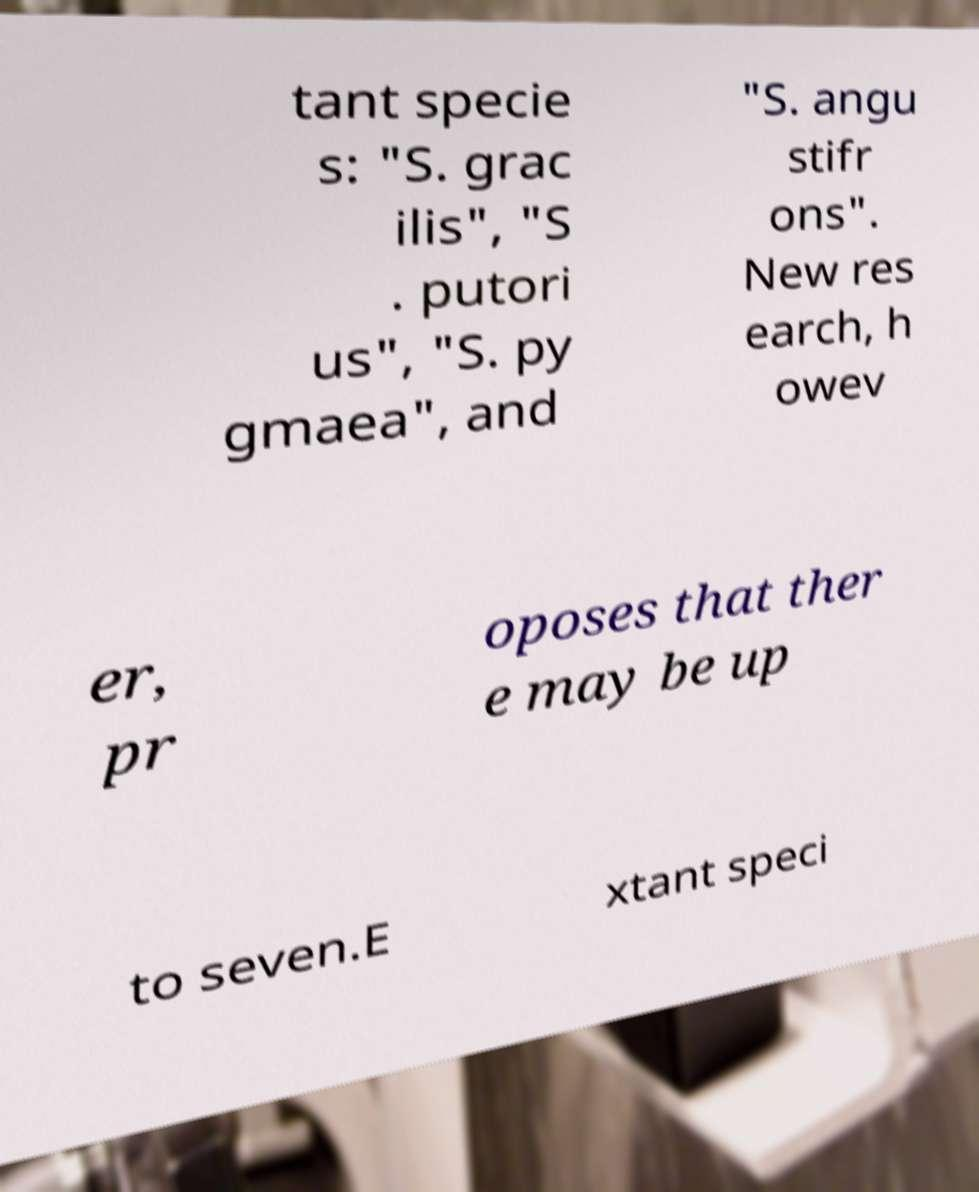Please identify and transcribe the text found in this image. tant specie s: "S. grac ilis", "S . putori us", "S. py gmaea", and "S. angu stifr ons". New res earch, h owev er, pr oposes that ther e may be up to seven.E xtant speci 